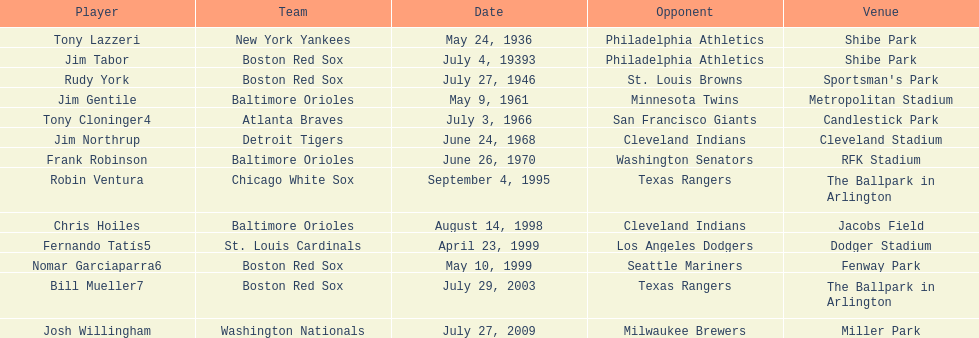When was the game featuring the detroit tigers and cleveland indians held? June 24, 1968. 